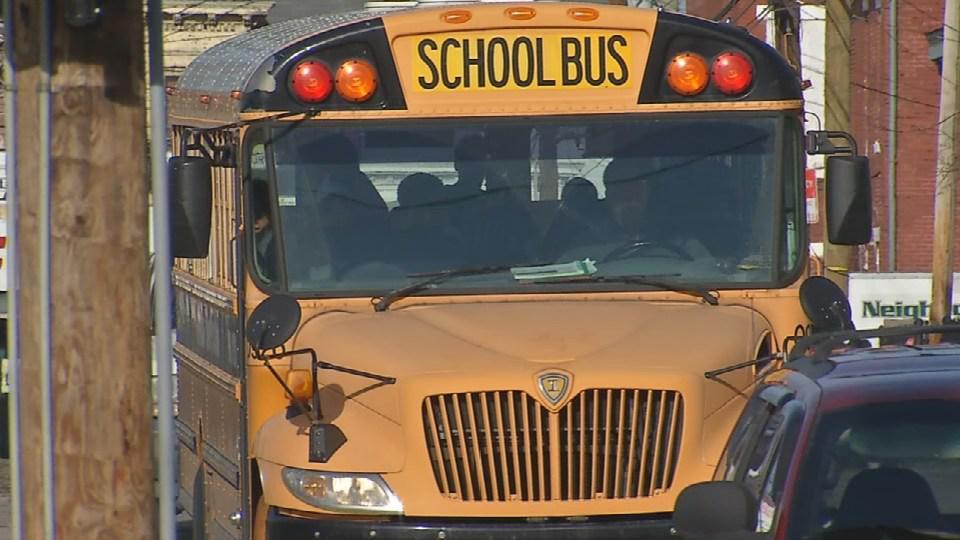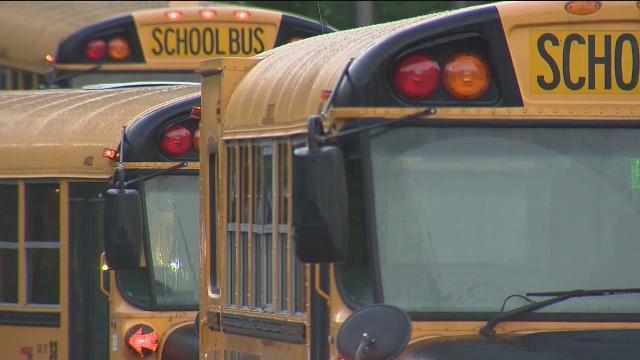The first image is the image on the left, the second image is the image on the right. Evaluate the accuracy of this statement regarding the images: "There are exactly two buses.". Is it true? Answer yes or no. No. The first image is the image on the left, the second image is the image on the right. Assess this claim about the two images: "Two rectangular rear view mirrors are visible in the righthand image but neither are located on the right side of the image.". Correct or not? Answer yes or no. Yes. 